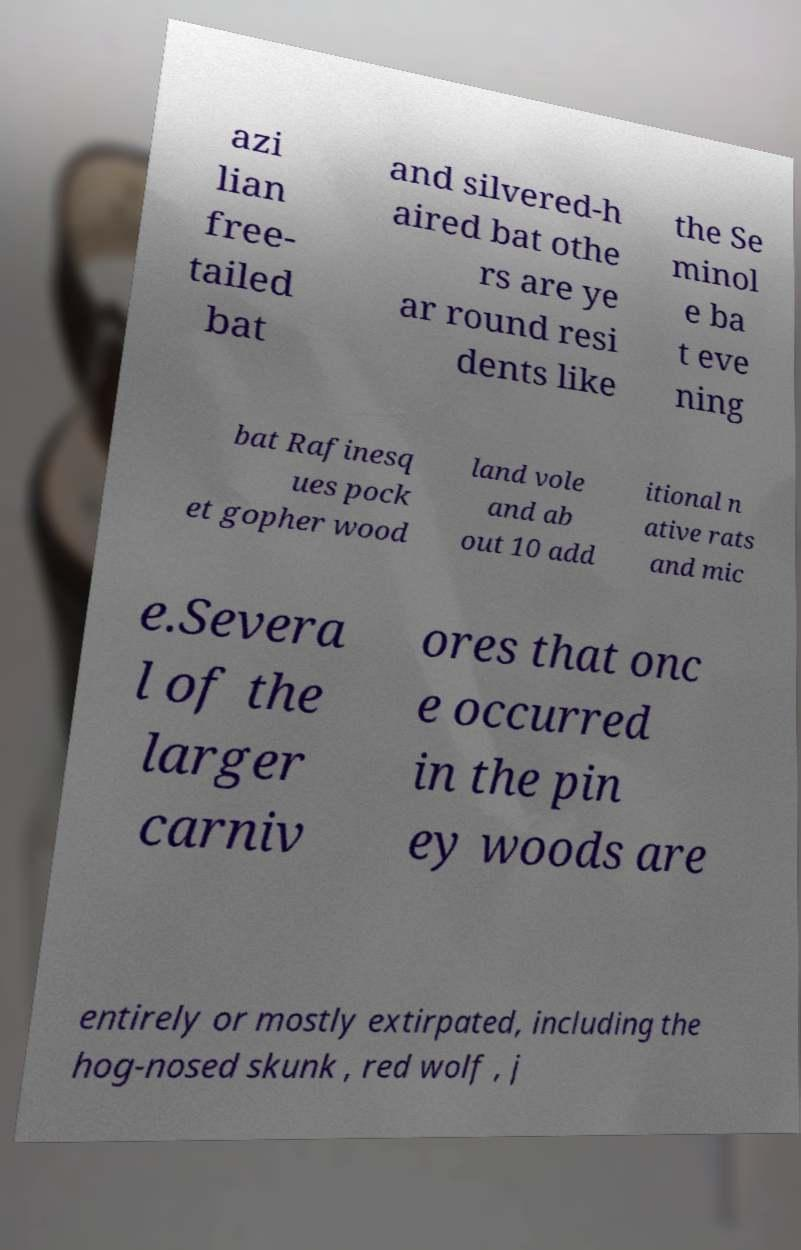Can you read and provide the text displayed in the image?This photo seems to have some interesting text. Can you extract and type it out for me? azi lian free- tailed bat and silvered-h aired bat othe rs are ye ar round resi dents like the Se minol e ba t eve ning bat Rafinesq ues pock et gopher wood land vole and ab out 10 add itional n ative rats and mic e.Severa l of the larger carniv ores that onc e occurred in the pin ey woods are entirely or mostly extirpated, including the hog-nosed skunk , red wolf , j 